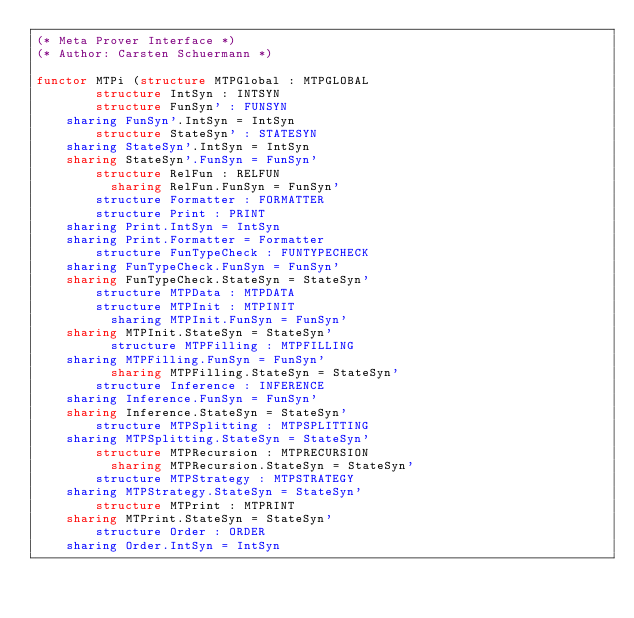<code> <loc_0><loc_0><loc_500><loc_500><_SML_>(* Meta Prover Interface *)
(* Author: Carsten Schuermann *)

functor MTPi (structure MTPGlobal : MTPGLOBAL
	      structure IntSyn : INTSYN
	      structure FunSyn' : FUNSYN
		sharing FunSyn'.IntSyn = IntSyn
	      structure StateSyn' : STATESYN
		sharing StateSyn'.IntSyn = IntSyn
		sharing StateSyn'.FunSyn = FunSyn'
	      structure RelFun : RELFUN
	        sharing RelFun.FunSyn = FunSyn'
	      structure Formatter : FORMATTER
	      structure Print : PRINT
		sharing Print.IntSyn = IntSyn
		sharing Print.Formatter = Formatter
	      structure FunTypeCheck : FUNTYPECHECK
		sharing FunTypeCheck.FunSyn = FunSyn'
		sharing FunTypeCheck.StateSyn = StateSyn'
	      structure MTPData : MTPDATA
	      structure MTPInit : MTPINIT
	        sharing MTPInit.FunSyn = FunSyn'
		sharing MTPInit.StateSyn = StateSyn'
  	      structure MTPFilling : MTPFILLING
		sharing MTPFilling.FunSyn = FunSyn'
	        sharing MTPFilling.StateSyn = StateSyn'
	      structure Inference : INFERENCE
		sharing Inference.FunSyn = FunSyn'
		sharing Inference.StateSyn = StateSyn'
	      structure MTPSplitting : MTPSPLITTING
		sharing MTPSplitting.StateSyn = StateSyn'
	      structure MTPRecursion : MTPRECURSION
	        sharing MTPRecursion.StateSyn = StateSyn'
	      structure MTPStrategy : MTPSTRATEGY
		sharing MTPStrategy.StateSyn = StateSyn'
	      structure MTPrint : MTPRINT
		sharing MTPrint.StateSyn = StateSyn'
	      structure Order : ORDER
		sharing Order.IntSyn = IntSyn</code> 